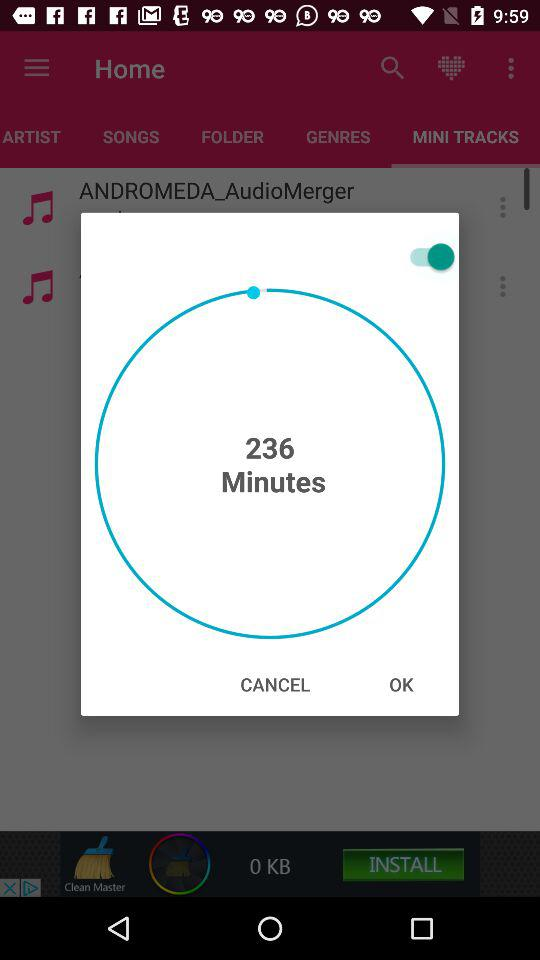What is the given duration? The given duration is 236 minutes. 